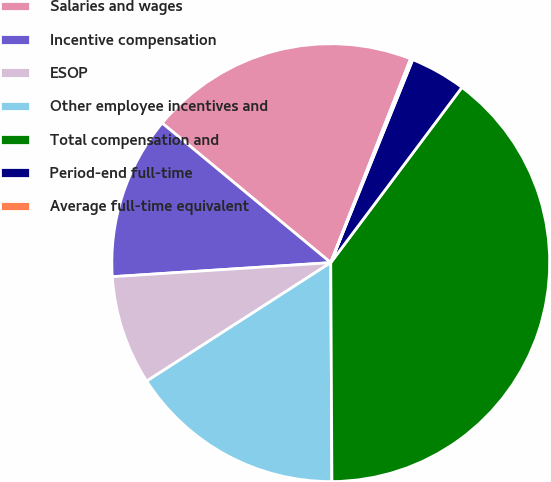Convert chart to OTSL. <chart><loc_0><loc_0><loc_500><loc_500><pie_chart><fcel>Salaries and wages<fcel>Incentive compensation<fcel>ESOP<fcel>Other employee incentives and<fcel>Total compensation and<fcel>Period-end full-time<fcel>Average full-time equivalent<nl><fcel>19.93%<fcel>12.03%<fcel>8.08%<fcel>15.98%<fcel>39.69%<fcel>4.12%<fcel>0.17%<nl></chart> 